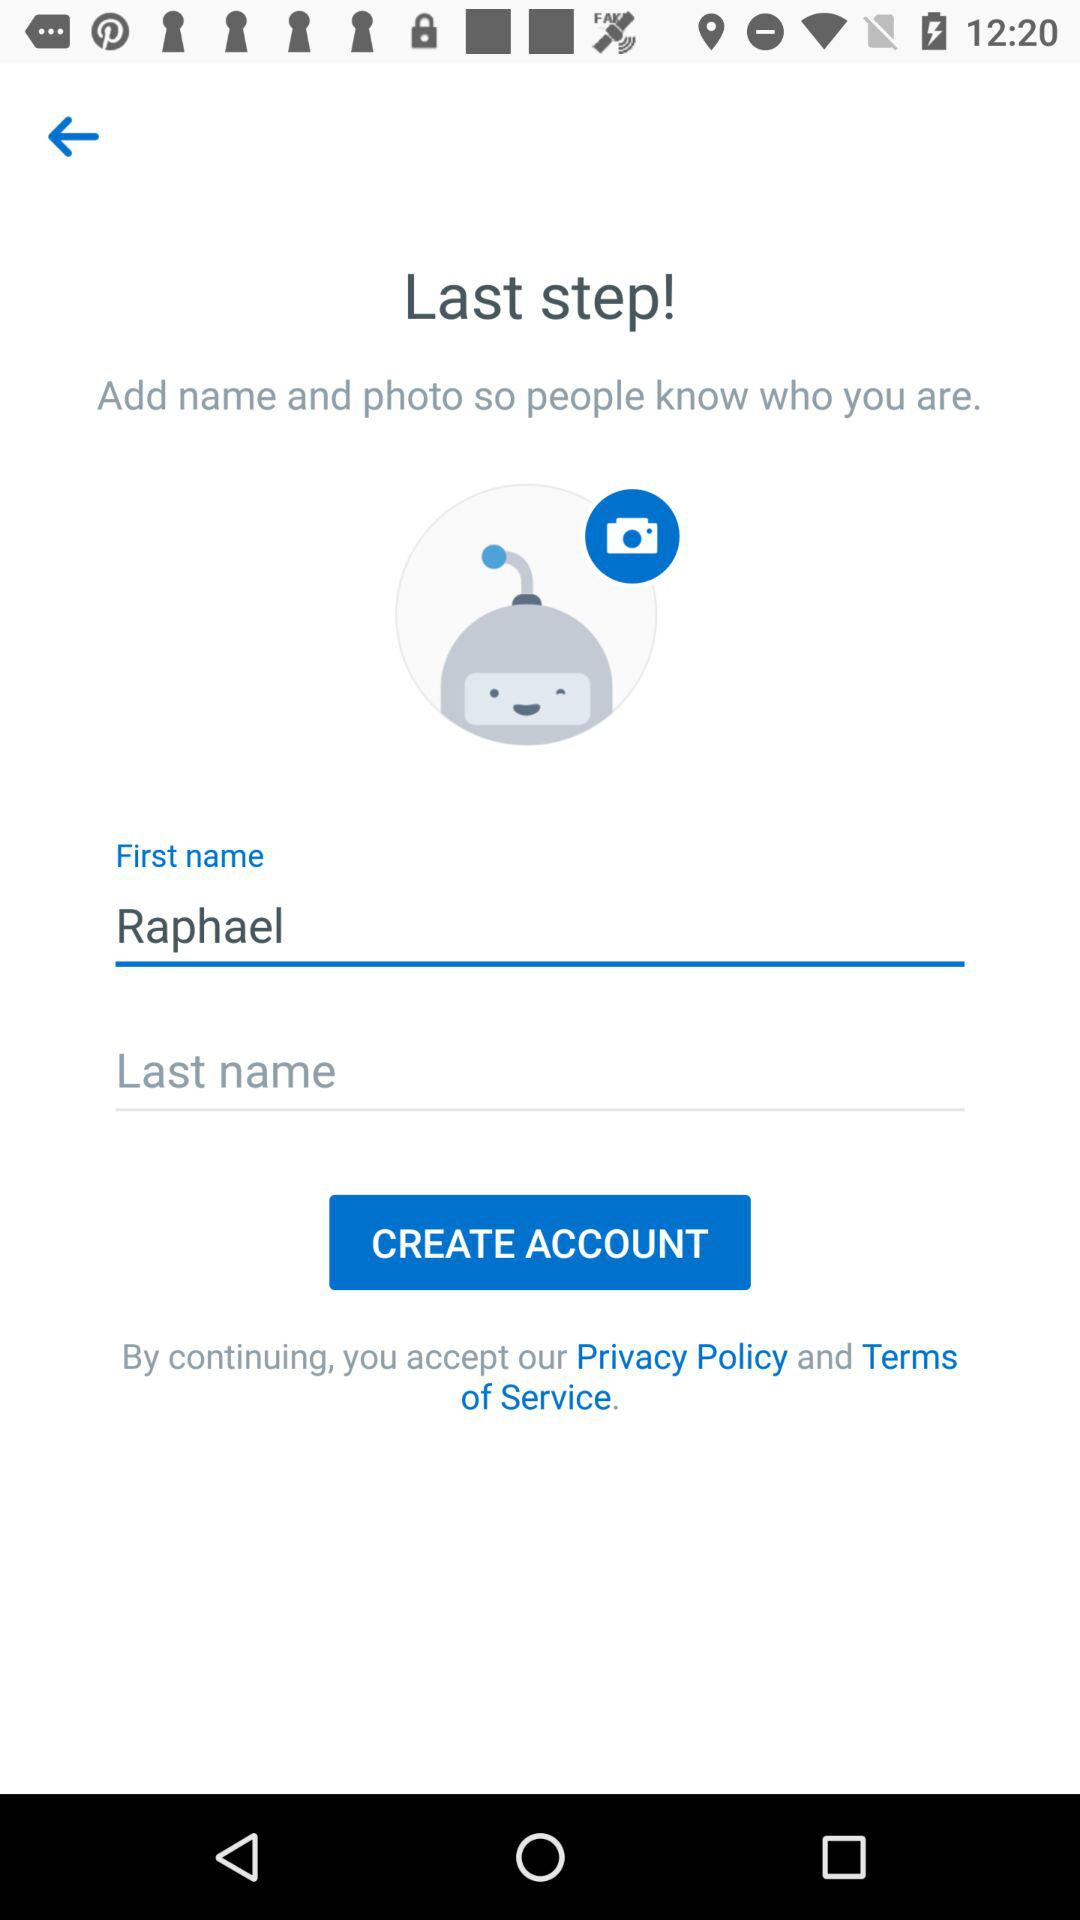What is the first name of the user? The first name of the user is Raphael. 